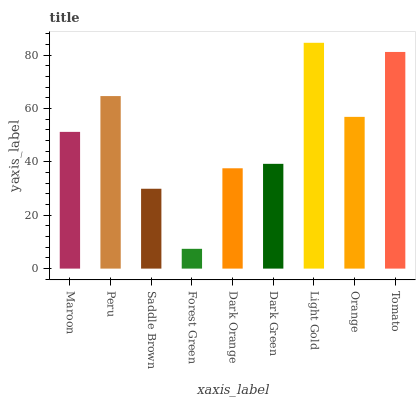Is Forest Green the minimum?
Answer yes or no. Yes. Is Light Gold the maximum?
Answer yes or no. Yes. Is Peru the minimum?
Answer yes or no. No. Is Peru the maximum?
Answer yes or no. No. Is Peru greater than Maroon?
Answer yes or no. Yes. Is Maroon less than Peru?
Answer yes or no. Yes. Is Maroon greater than Peru?
Answer yes or no. No. Is Peru less than Maroon?
Answer yes or no. No. Is Maroon the high median?
Answer yes or no. Yes. Is Maroon the low median?
Answer yes or no. Yes. Is Light Gold the high median?
Answer yes or no. No. Is Peru the low median?
Answer yes or no. No. 